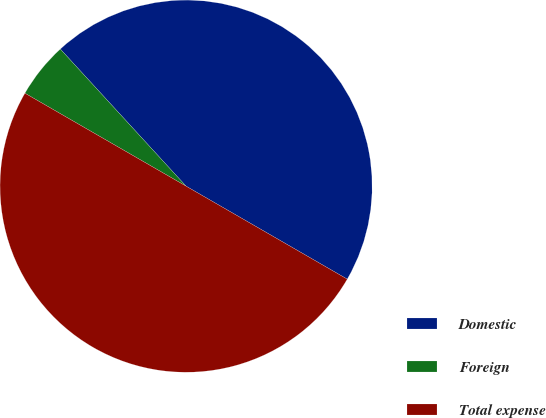Convert chart to OTSL. <chart><loc_0><loc_0><loc_500><loc_500><pie_chart><fcel>Domestic<fcel>Foreign<fcel>Total expense<nl><fcel>45.14%<fcel>4.86%<fcel>50.0%<nl></chart> 